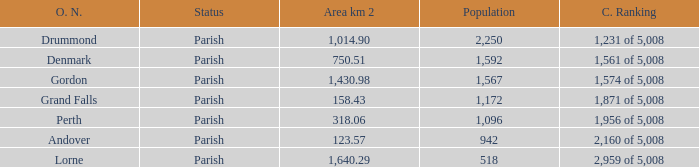Which parish has an area of 750.51? Denmark. 